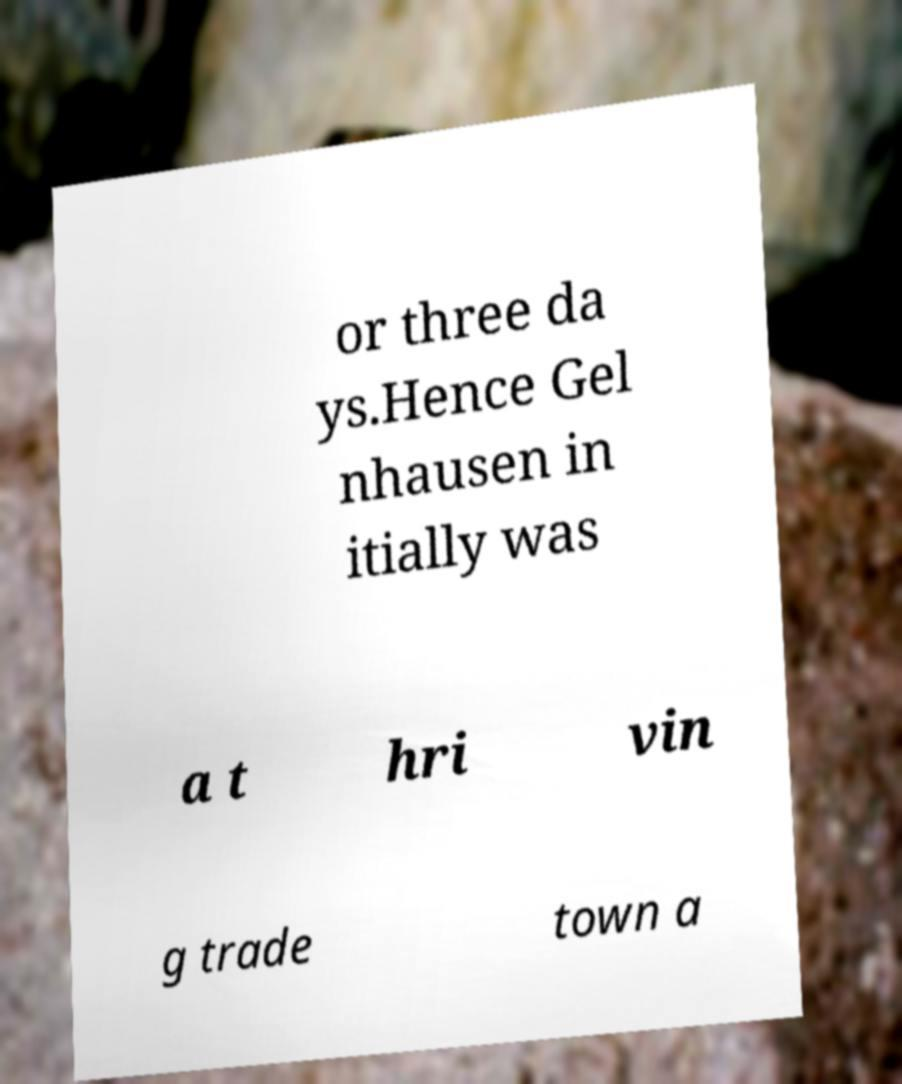What messages or text are displayed in this image? I need them in a readable, typed format. or three da ys.Hence Gel nhausen in itially was a t hri vin g trade town a 